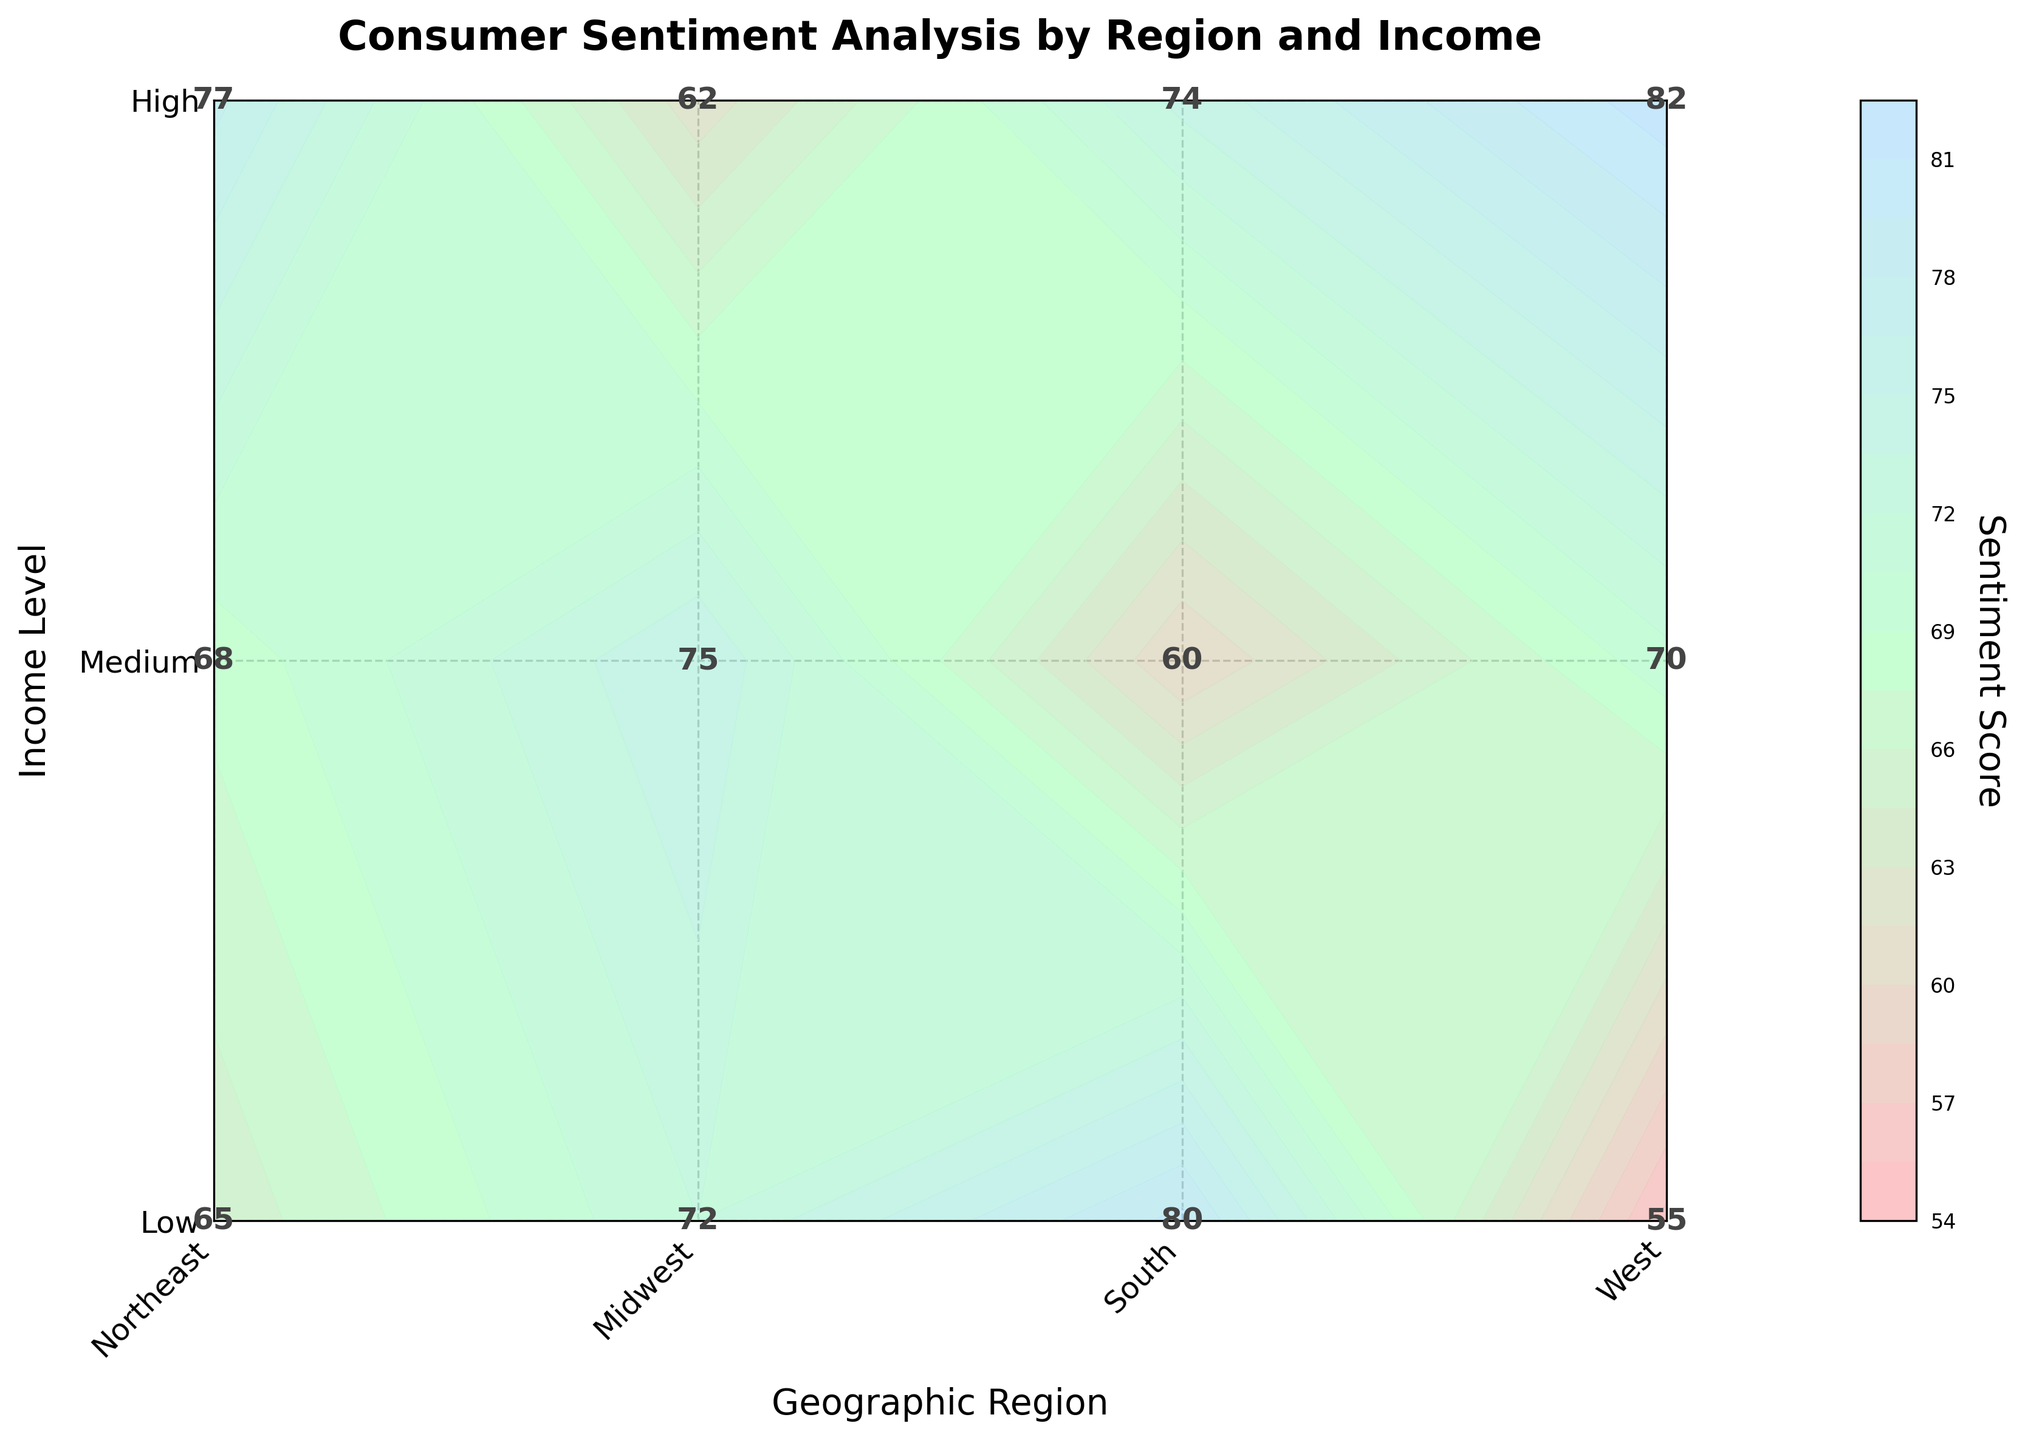What's the highest sentiment score in the Northeast region? The Northeast region has sentiment scores for Low, Medium, and High-income levels plotted as 65, 72, and 80 respectively. The highest among them is 80.
Answer: 80 Which region has the highest average sentiment score? To find the highest average sentiment score, calculate the average for each region: Northeast (65+72+80)/3 = 72.33, Midwest (55+68+75)/3 = 66, South (60+70+77)/3 = 69, West (62+74+82)/3 = 72.67. The West has the highest average.
Answer: West What is the sentiment score for Medium income level in the South? Locate the Medium income level row for the South region,  which shows the sentiment score as 70.
Answer: 70 Which income level in the Midwest region has the lowest sentiment score? For the Midwest region, the sentiment scores are 55 (Low), 68 (Medium), and 75 (High). The lowest among these is 55, which corresponds to the Low-income level.
Answer: Low What is the color variation used in the plot and what does it signify? The color variation ranges from shades of light pink to light green to light blue. This gradient reflects increasing sentiment scores from lower to higher values, with lighter shades depicting lower scores and darker shades depicting higher scores.
Answer: Light pink to light blue indicating increasing scores How does the sentiment score for High income level in the West compare to that in the South? The sentiment score for High income level in the West is 82, whereas in the South it is 77. Comparing these, the score in the West (82) is higher than in the South (77).
Answer: Higher in the West What is the difference in sentiment scores between High and Low income levels in the Midwest? In the Midwest, the sentiment scores are 55 for Low income and 75 for High income. The difference is calculated as 75 - 55 = 20.
Answer: 20 What regions have sentiment scores above 70 for Medium income level? Check each region for the Medium income level sentiment score: Northeast (72), Midwest (68), South (70), West (74). The regions with scores above 70 are Northeast and West.
Answer: Northeast and West How is the grid structured in the contour plot? The grid has labeled axes where the x-axis represents Geographic Region and the y-axis represents Income Level. Each intersection of x and y denotes a sentiment score. The contour lines and color variations connect similar sentiment scores across the grid.
Answer: Labeled axes with geographic regions and income levels What does the lowest sentiment score in the entire plot represent? Across all regions, the lowest sentiment score is 55, which is found at the intersection of Low-income level in the Midwest region.
Answer: 55 (Midwest, Low-income) 